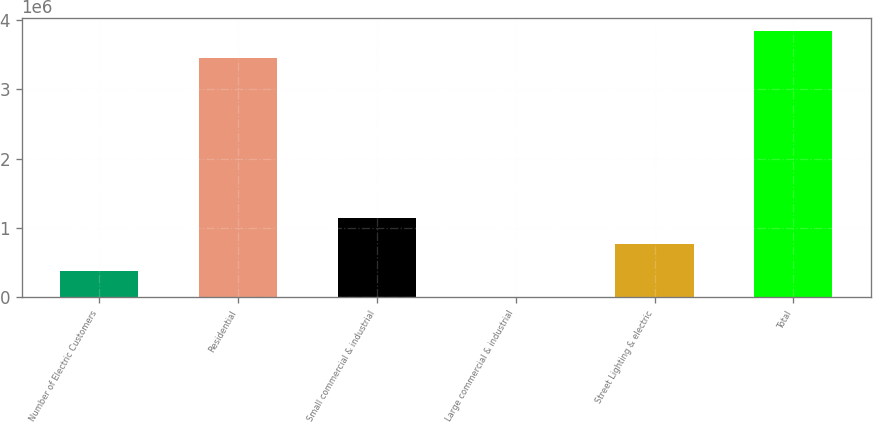Convert chart. <chart><loc_0><loc_0><loc_500><loc_500><bar_chart><fcel>Number of Electric Customers<fcel>Residential<fcel>Small commercial & industrial<fcel>Large commercial & industrial<fcel>Street Lighting & electric<fcel>Total<nl><fcel>384552<fcel>3.45555e+06<fcel>1.14969e+06<fcel>1980<fcel>767123<fcel>3.83812e+06<nl></chart> 